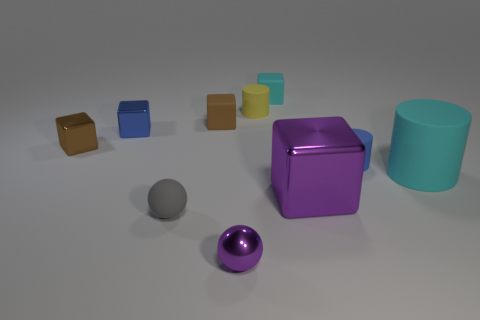Which objects in the image are of similar shapes and how do they differ in other aspects? The purple and gray objects are spherical, sharing a similar shape. However, they differ in size and color: the purple is larger and has a metallic sheen, while the gray is smaller and has a matte finish. The cubes are all of the same shape but vary in size and color, ranging from brown and blue to yellow, teal, and the most dominant purple cube. 